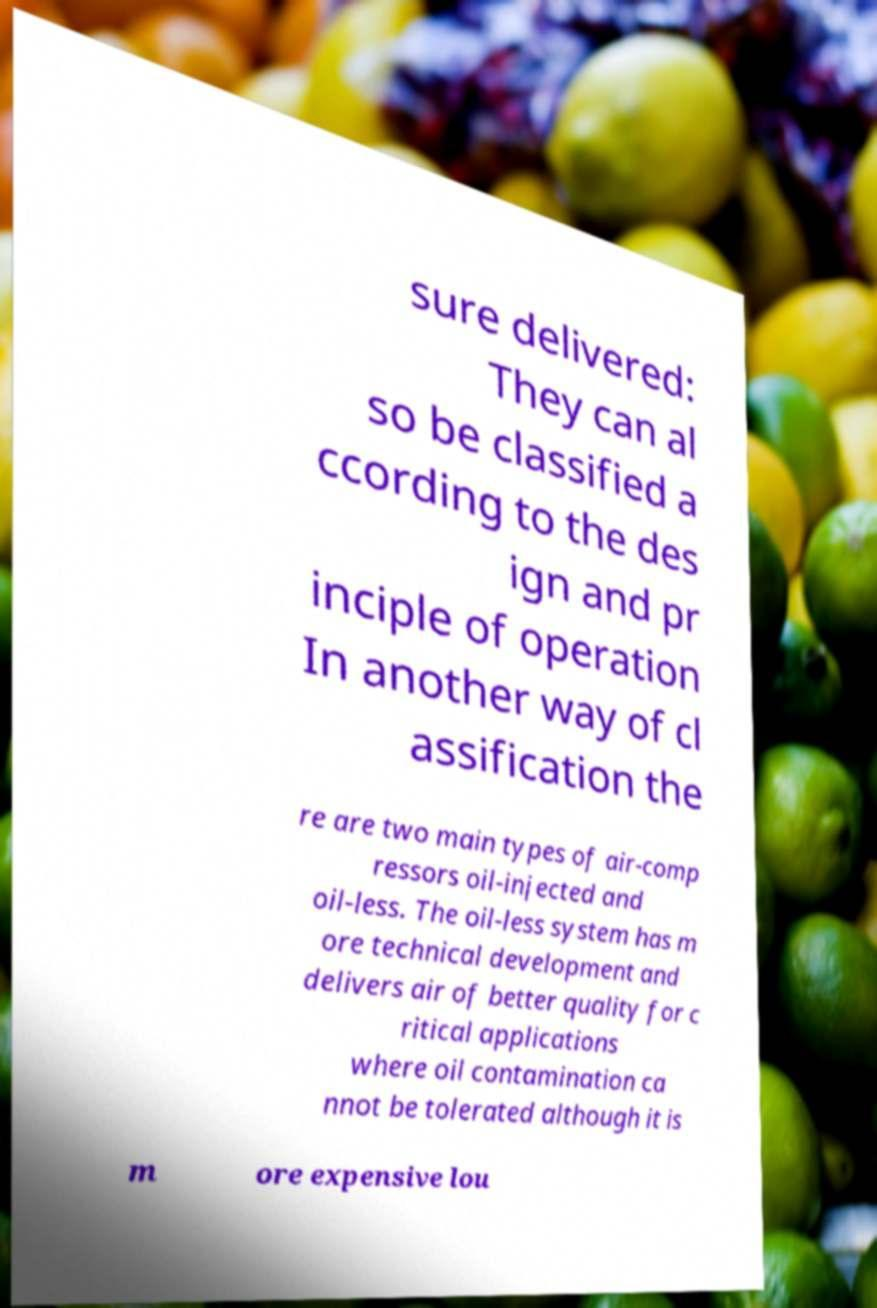Could you extract and type out the text from this image? sure delivered: They can al so be classified a ccording to the des ign and pr inciple of operation In another way of cl assification the re are two main types of air-comp ressors oil-injected and oil-less. The oil-less system has m ore technical development and delivers air of better quality for c ritical applications where oil contamination ca nnot be tolerated although it is m ore expensive lou 